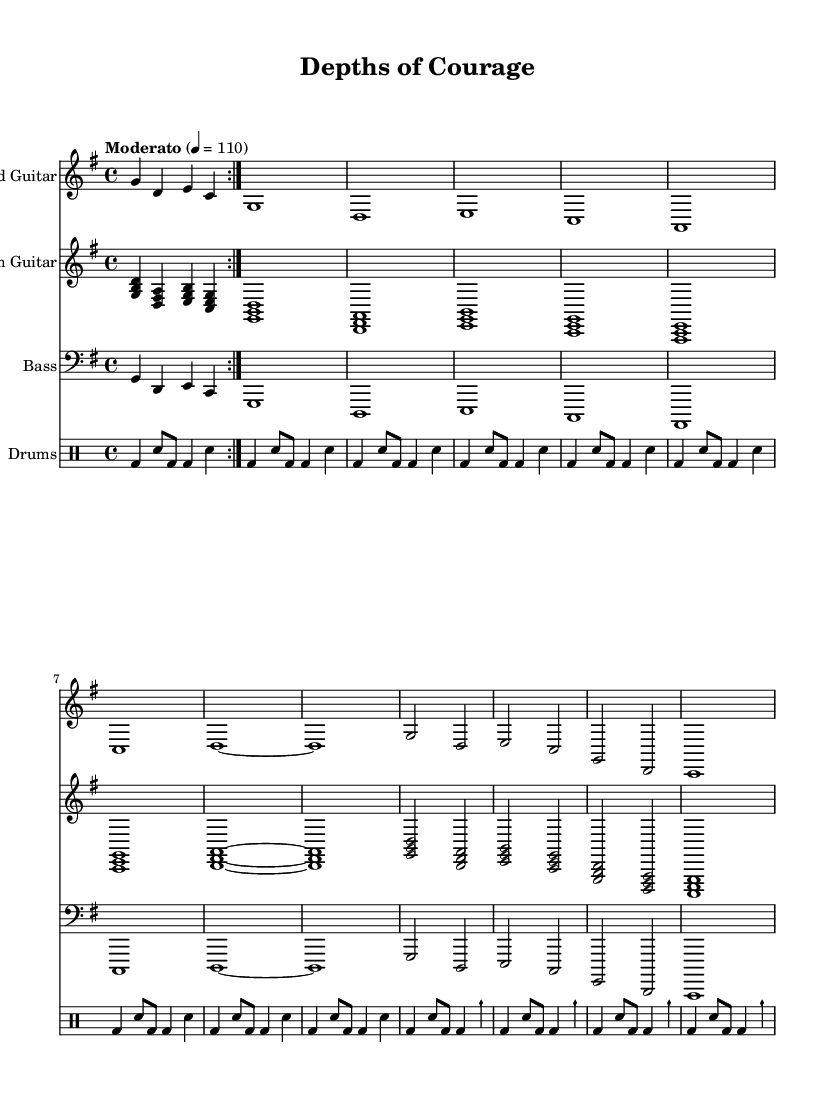What is the key signature of this music? The key signature is G major, which has one sharp (F#) indicated on the staff at the beginning.
Answer: G major What is the time signature of this piece? The time signature is 4/4, as shown at the beginning of the staff with the numbers 4 and 4.
Answer: 4/4 What is the tempo marking of the piece? The tempo marking states "Moderato" with a metronome marking of 110 beats per minute. This indicates a moderate speed for the performance.
Answer: Moderato, 110 How many measures are repeated in the first volta? In the first volta, there are four measures that are repeated as indicated by the repeat signs.
Answer: Four measures What instruments are featured in this piece? The piece features Lead Guitar, Rhythm Guitar, Bass, and Drums, as noted at the beginning of each staff.
Answer: Lead Guitar, Rhythm Guitar, Bass, Drums How does the dynamic build-up progress through the piece? The build-up is evident as the piece progresses, with crescendos leading towards stronger emphasis. The overall structure suggests a rise in intensity particularly in the electric guitar and drums.
Answer: Crescendo What is the final note value of the bass guitar part? The final note value of the bass guitar part is a whole note (c1), which indicates a sustained sound at the end of the section.
Answer: Whole note 